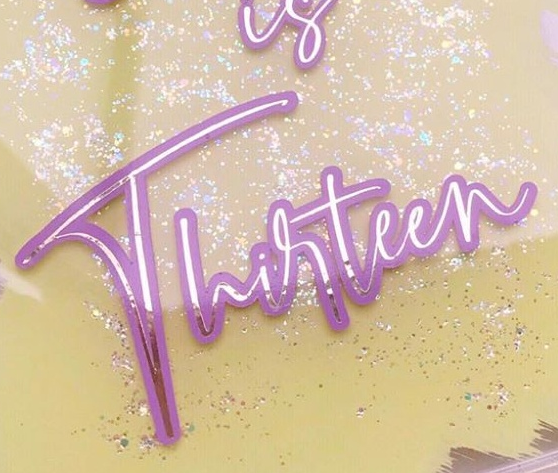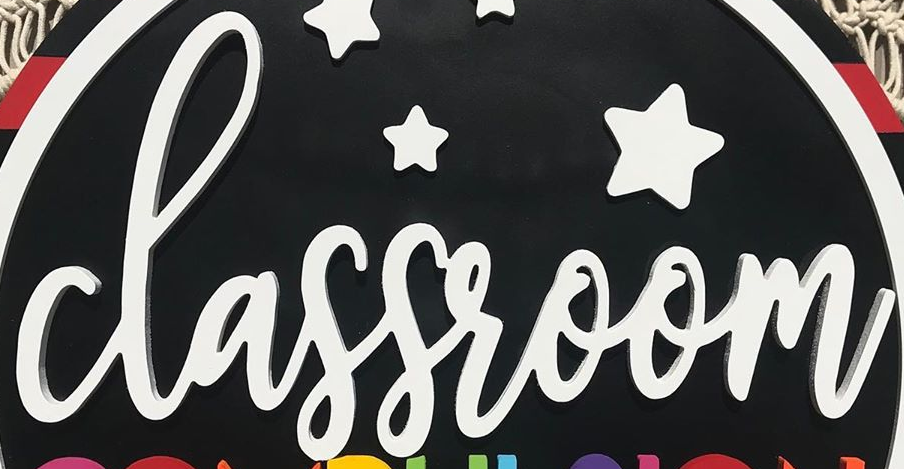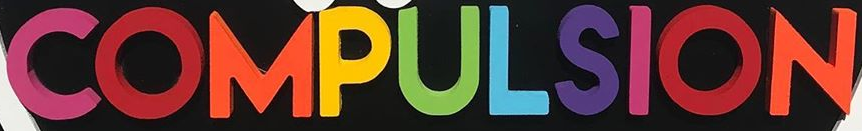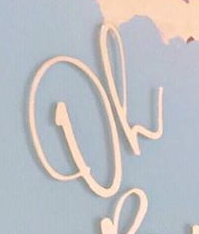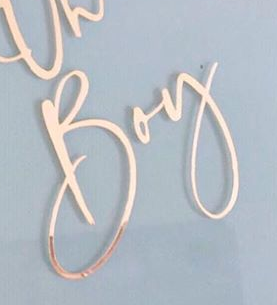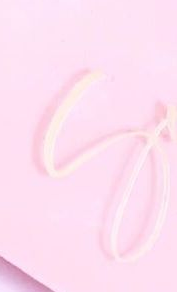Read the text content from these images in order, separated by a semicolon. Thirteen; classroom; COMPULSION; Oh; Boy; S 